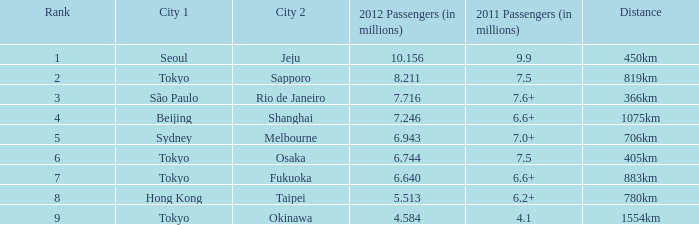What is the name of the first city on the route with 6.6 million or more passengers in 2011 and a distance of 1075 kilometers? Beijing. 